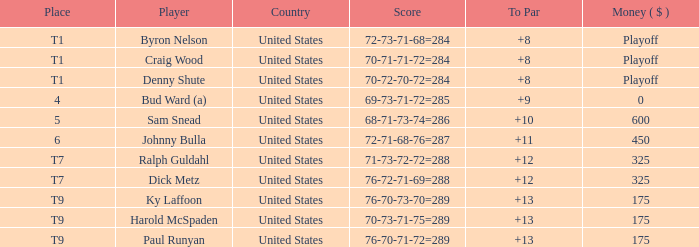What is the total amount sam snead won? 600.0. 